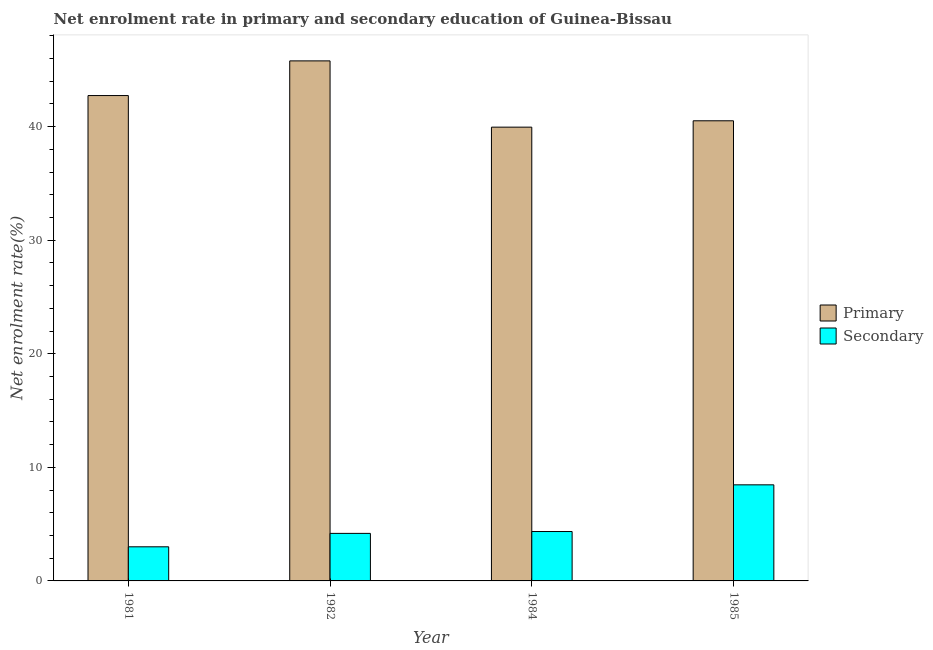How many different coloured bars are there?
Your answer should be compact. 2. Are the number of bars per tick equal to the number of legend labels?
Your response must be concise. Yes. How many bars are there on the 4th tick from the left?
Provide a short and direct response. 2. How many bars are there on the 2nd tick from the right?
Ensure brevity in your answer.  2. In how many cases, is the number of bars for a given year not equal to the number of legend labels?
Offer a very short reply. 0. What is the enrollment rate in secondary education in 1985?
Your answer should be compact. 8.46. Across all years, what is the maximum enrollment rate in secondary education?
Keep it short and to the point. 8.46. Across all years, what is the minimum enrollment rate in primary education?
Your answer should be very brief. 39.96. In which year was the enrollment rate in secondary education maximum?
Give a very brief answer. 1985. What is the total enrollment rate in primary education in the graph?
Make the answer very short. 169.01. What is the difference between the enrollment rate in secondary education in 1982 and that in 1984?
Keep it short and to the point. -0.16. What is the difference between the enrollment rate in primary education in 1984 and the enrollment rate in secondary education in 1985?
Offer a very short reply. -0.56. What is the average enrollment rate in secondary education per year?
Keep it short and to the point. 5. What is the ratio of the enrollment rate in secondary education in 1982 to that in 1984?
Keep it short and to the point. 0.96. Is the enrollment rate in secondary education in 1981 less than that in 1985?
Make the answer very short. Yes. What is the difference between the highest and the second highest enrollment rate in primary education?
Your answer should be compact. 3.05. What is the difference between the highest and the lowest enrollment rate in primary education?
Your response must be concise. 5.84. In how many years, is the enrollment rate in secondary education greater than the average enrollment rate in secondary education taken over all years?
Your response must be concise. 1. Is the sum of the enrollment rate in secondary education in 1982 and 1984 greater than the maximum enrollment rate in primary education across all years?
Keep it short and to the point. Yes. What does the 2nd bar from the left in 1985 represents?
Your answer should be very brief. Secondary. What does the 2nd bar from the right in 1981 represents?
Provide a short and direct response. Primary. How many bars are there?
Make the answer very short. 8. What is the difference between two consecutive major ticks on the Y-axis?
Offer a terse response. 10. Does the graph contain grids?
Keep it short and to the point. No. Where does the legend appear in the graph?
Your answer should be very brief. Center right. What is the title of the graph?
Offer a terse response. Net enrolment rate in primary and secondary education of Guinea-Bissau. Does "From Government" appear as one of the legend labels in the graph?
Make the answer very short. No. What is the label or title of the X-axis?
Ensure brevity in your answer.  Year. What is the label or title of the Y-axis?
Provide a short and direct response. Net enrolment rate(%). What is the Net enrolment rate(%) of Primary in 1981?
Your answer should be very brief. 42.74. What is the Net enrolment rate(%) in Secondary in 1981?
Offer a very short reply. 3. What is the Net enrolment rate(%) of Primary in 1982?
Keep it short and to the point. 45.79. What is the Net enrolment rate(%) in Secondary in 1982?
Offer a terse response. 4.19. What is the Net enrolment rate(%) of Primary in 1984?
Provide a succinct answer. 39.96. What is the Net enrolment rate(%) in Secondary in 1984?
Ensure brevity in your answer.  4.35. What is the Net enrolment rate(%) of Primary in 1985?
Offer a very short reply. 40.52. What is the Net enrolment rate(%) in Secondary in 1985?
Keep it short and to the point. 8.46. Across all years, what is the maximum Net enrolment rate(%) in Primary?
Your answer should be very brief. 45.79. Across all years, what is the maximum Net enrolment rate(%) in Secondary?
Provide a succinct answer. 8.46. Across all years, what is the minimum Net enrolment rate(%) of Primary?
Your answer should be very brief. 39.96. Across all years, what is the minimum Net enrolment rate(%) of Secondary?
Your response must be concise. 3. What is the total Net enrolment rate(%) of Primary in the graph?
Provide a succinct answer. 169.01. What is the total Net enrolment rate(%) in Secondary in the graph?
Make the answer very short. 20. What is the difference between the Net enrolment rate(%) in Primary in 1981 and that in 1982?
Your answer should be very brief. -3.05. What is the difference between the Net enrolment rate(%) of Secondary in 1981 and that in 1982?
Your response must be concise. -1.18. What is the difference between the Net enrolment rate(%) of Primary in 1981 and that in 1984?
Make the answer very short. 2.78. What is the difference between the Net enrolment rate(%) of Secondary in 1981 and that in 1984?
Your answer should be very brief. -1.35. What is the difference between the Net enrolment rate(%) of Primary in 1981 and that in 1985?
Keep it short and to the point. 2.22. What is the difference between the Net enrolment rate(%) of Secondary in 1981 and that in 1985?
Give a very brief answer. -5.46. What is the difference between the Net enrolment rate(%) of Primary in 1982 and that in 1984?
Make the answer very short. 5.84. What is the difference between the Net enrolment rate(%) of Secondary in 1982 and that in 1984?
Your response must be concise. -0.16. What is the difference between the Net enrolment rate(%) of Primary in 1982 and that in 1985?
Your answer should be compact. 5.28. What is the difference between the Net enrolment rate(%) in Secondary in 1982 and that in 1985?
Offer a terse response. -4.28. What is the difference between the Net enrolment rate(%) in Primary in 1984 and that in 1985?
Provide a short and direct response. -0.56. What is the difference between the Net enrolment rate(%) in Secondary in 1984 and that in 1985?
Your response must be concise. -4.11. What is the difference between the Net enrolment rate(%) of Primary in 1981 and the Net enrolment rate(%) of Secondary in 1982?
Offer a very short reply. 38.55. What is the difference between the Net enrolment rate(%) of Primary in 1981 and the Net enrolment rate(%) of Secondary in 1984?
Offer a very short reply. 38.39. What is the difference between the Net enrolment rate(%) in Primary in 1981 and the Net enrolment rate(%) in Secondary in 1985?
Your answer should be compact. 34.28. What is the difference between the Net enrolment rate(%) in Primary in 1982 and the Net enrolment rate(%) in Secondary in 1984?
Make the answer very short. 41.44. What is the difference between the Net enrolment rate(%) in Primary in 1982 and the Net enrolment rate(%) in Secondary in 1985?
Give a very brief answer. 37.33. What is the difference between the Net enrolment rate(%) in Primary in 1984 and the Net enrolment rate(%) in Secondary in 1985?
Your response must be concise. 31.5. What is the average Net enrolment rate(%) of Primary per year?
Make the answer very short. 42.25. What is the average Net enrolment rate(%) in Secondary per year?
Your answer should be very brief. 5. In the year 1981, what is the difference between the Net enrolment rate(%) of Primary and Net enrolment rate(%) of Secondary?
Your response must be concise. 39.74. In the year 1982, what is the difference between the Net enrolment rate(%) in Primary and Net enrolment rate(%) in Secondary?
Your answer should be very brief. 41.61. In the year 1984, what is the difference between the Net enrolment rate(%) in Primary and Net enrolment rate(%) in Secondary?
Offer a very short reply. 35.61. In the year 1985, what is the difference between the Net enrolment rate(%) in Primary and Net enrolment rate(%) in Secondary?
Ensure brevity in your answer.  32.06. What is the ratio of the Net enrolment rate(%) in Secondary in 1981 to that in 1982?
Keep it short and to the point. 0.72. What is the ratio of the Net enrolment rate(%) of Primary in 1981 to that in 1984?
Make the answer very short. 1.07. What is the ratio of the Net enrolment rate(%) in Secondary in 1981 to that in 1984?
Make the answer very short. 0.69. What is the ratio of the Net enrolment rate(%) in Primary in 1981 to that in 1985?
Offer a terse response. 1.05. What is the ratio of the Net enrolment rate(%) of Secondary in 1981 to that in 1985?
Give a very brief answer. 0.36. What is the ratio of the Net enrolment rate(%) of Primary in 1982 to that in 1984?
Offer a very short reply. 1.15. What is the ratio of the Net enrolment rate(%) of Secondary in 1982 to that in 1984?
Give a very brief answer. 0.96. What is the ratio of the Net enrolment rate(%) in Primary in 1982 to that in 1985?
Give a very brief answer. 1.13. What is the ratio of the Net enrolment rate(%) of Secondary in 1982 to that in 1985?
Offer a terse response. 0.49. What is the ratio of the Net enrolment rate(%) in Primary in 1984 to that in 1985?
Provide a succinct answer. 0.99. What is the ratio of the Net enrolment rate(%) in Secondary in 1984 to that in 1985?
Offer a terse response. 0.51. What is the difference between the highest and the second highest Net enrolment rate(%) of Primary?
Keep it short and to the point. 3.05. What is the difference between the highest and the second highest Net enrolment rate(%) of Secondary?
Offer a very short reply. 4.11. What is the difference between the highest and the lowest Net enrolment rate(%) of Primary?
Your answer should be compact. 5.84. What is the difference between the highest and the lowest Net enrolment rate(%) in Secondary?
Your answer should be very brief. 5.46. 